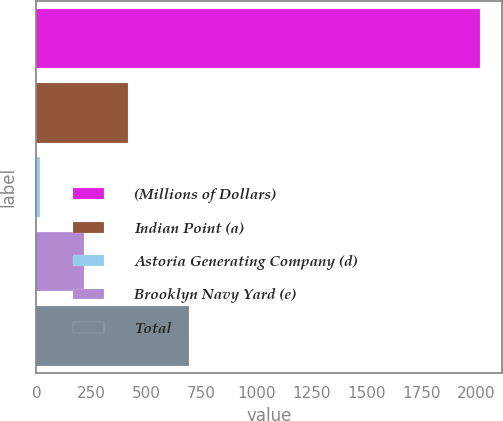Convert chart. <chart><loc_0><loc_0><loc_500><loc_500><bar_chart><fcel>(Millions of Dollars)<fcel>Indian Point (a)<fcel>Astoria Generating Company (d)<fcel>Brooklyn Navy Yard (e)<fcel>Total<nl><fcel>2016<fcel>416<fcel>16<fcel>216<fcel>692<nl></chart> 